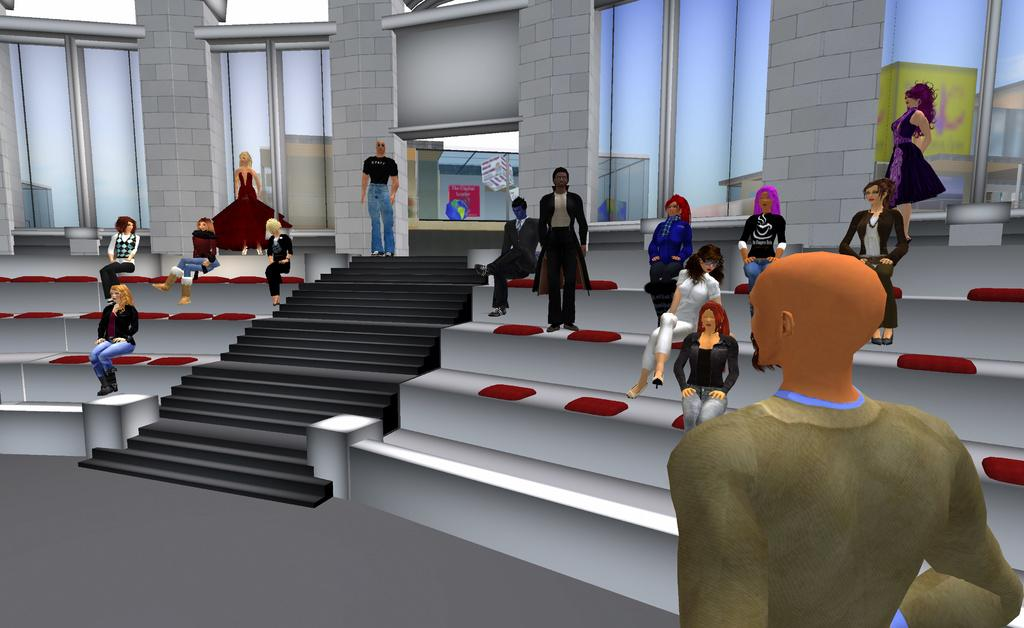What type of image is being described? The image is an animation. What are the people in the image doing? Some people are sitting, and some are standing in the image. Are there any architectural features in the image? Yes, there are stairs in the image. What can be seen in the background of the image? There are windows in the background of the image. What type of doctor can be seen attending to a patient in the image? There is no doctor or patient present in the image; it is an animation featuring people sitting and standing, stairs, and windows in the background. 